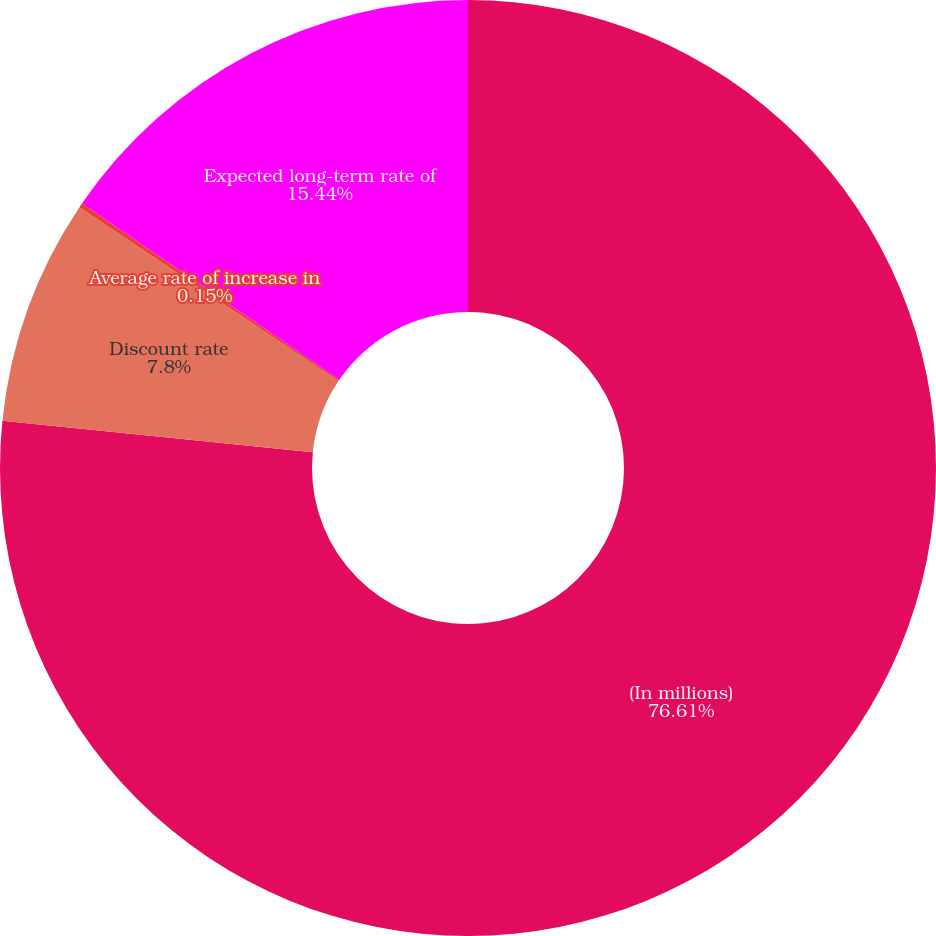Convert chart. <chart><loc_0><loc_0><loc_500><loc_500><pie_chart><fcel>(In millions)<fcel>Discount rate<fcel>Average rate of increase in<fcel>Expected long-term rate of<nl><fcel>76.61%<fcel>7.8%<fcel>0.15%<fcel>15.44%<nl></chart> 